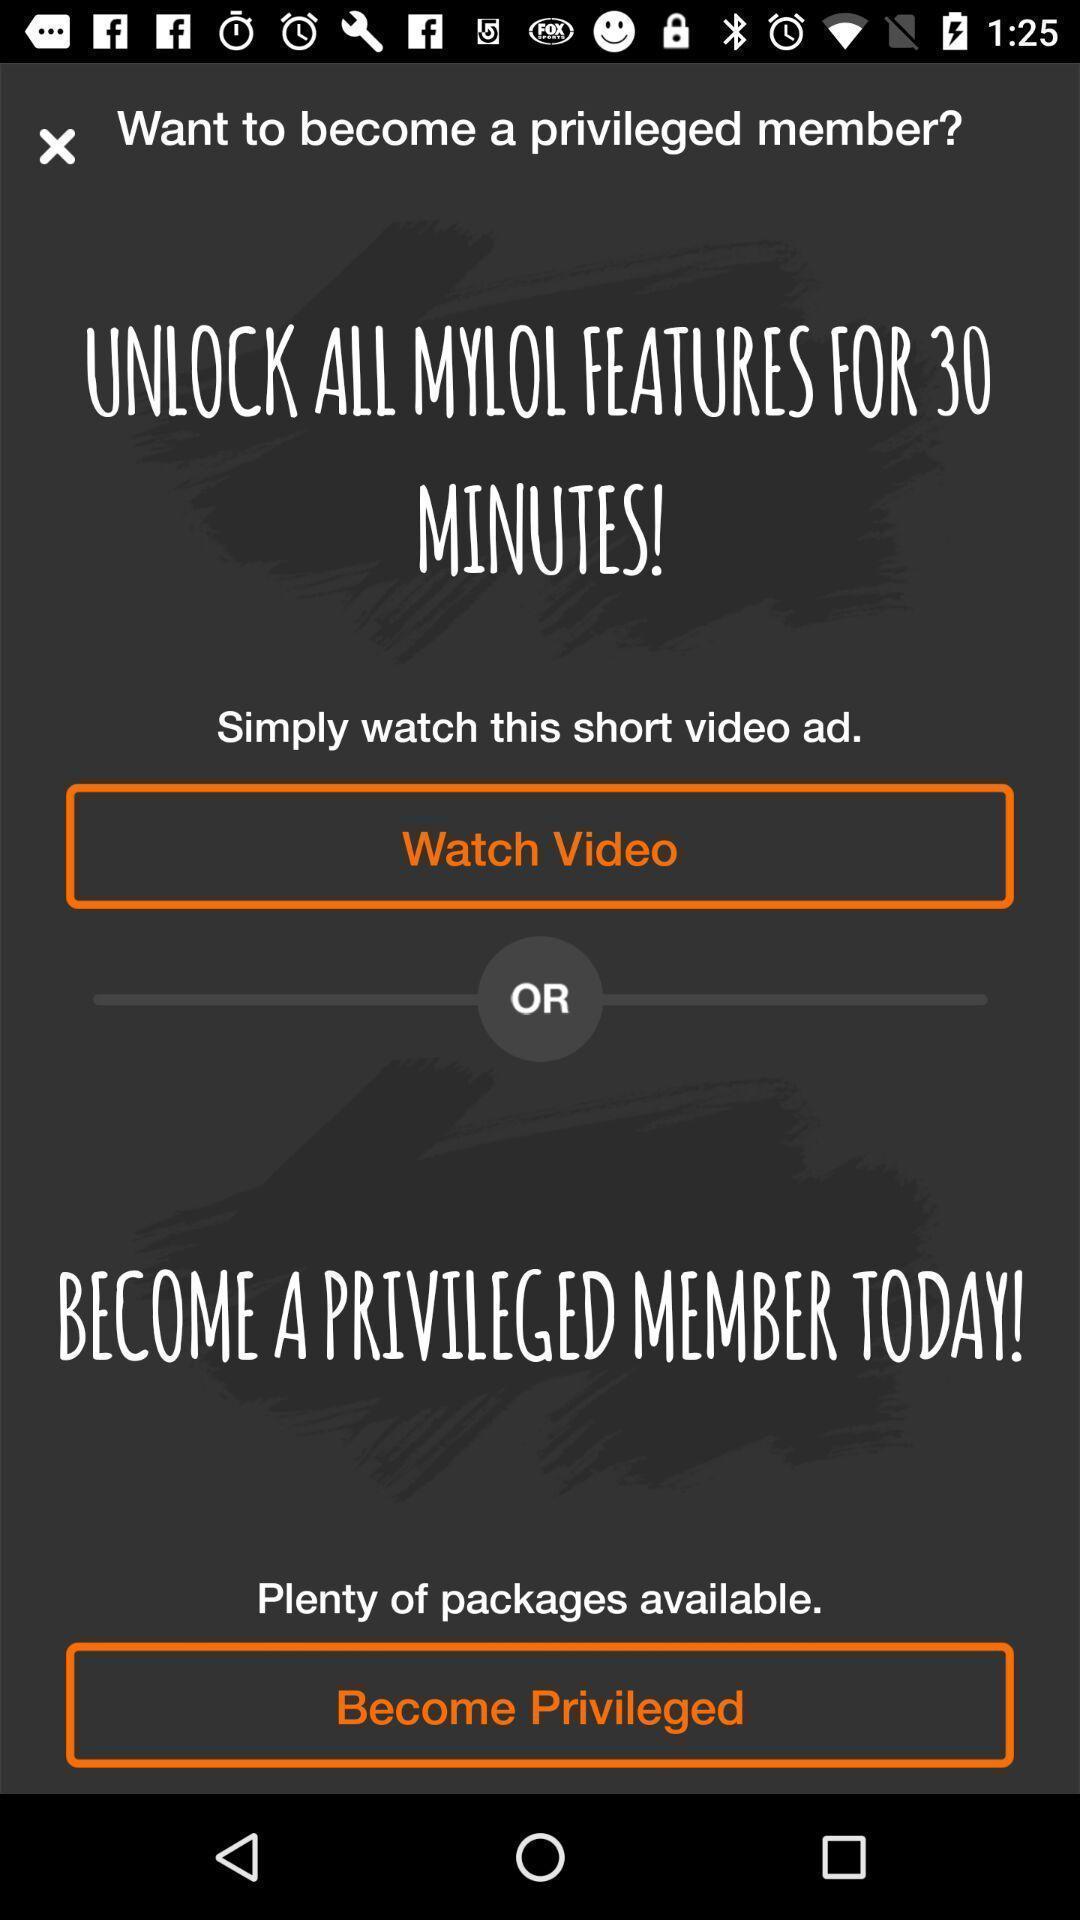Tell me about the visual elements in this screen capture. Screen displaying the screen page of a social network app. 